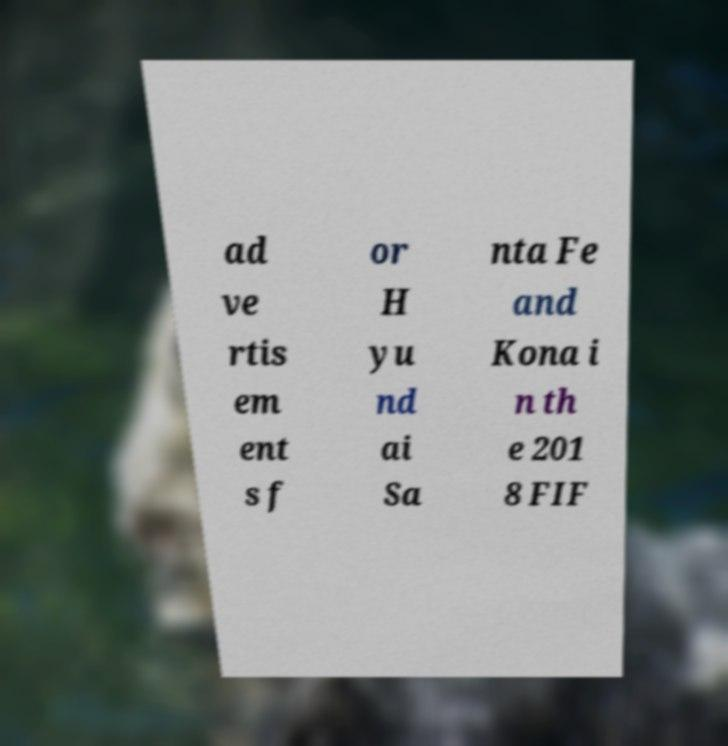Please read and relay the text visible in this image. What does it say? ad ve rtis em ent s f or H yu nd ai Sa nta Fe and Kona i n th e 201 8 FIF 